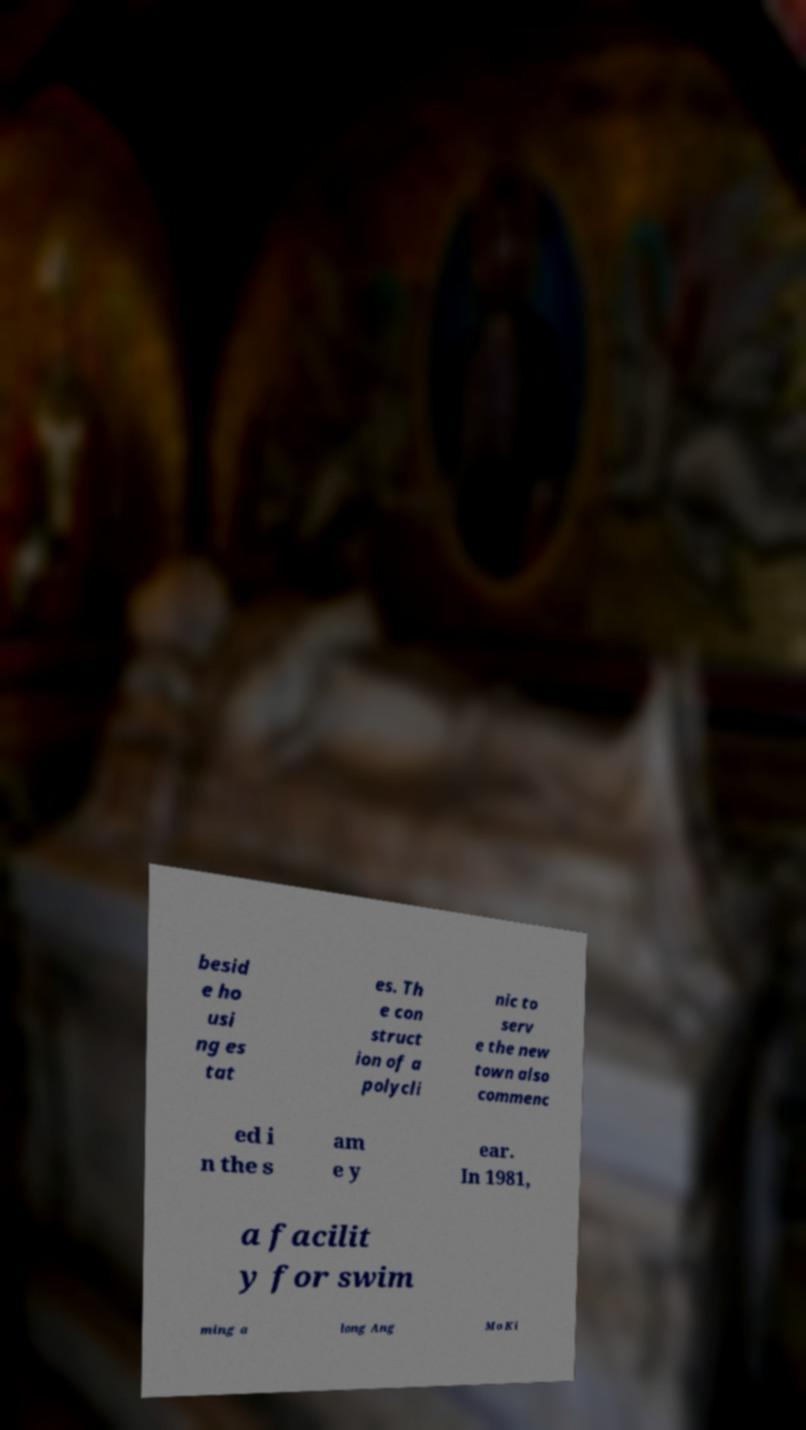What messages or text are displayed in this image? I need them in a readable, typed format. besid e ho usi ng es tat es. Th e con struct ion of a polycli nic to serv e the new town also commenc ed i n the s am e y ear. In 1981, a facilit y for swim ming a long Ang Mo Ki 